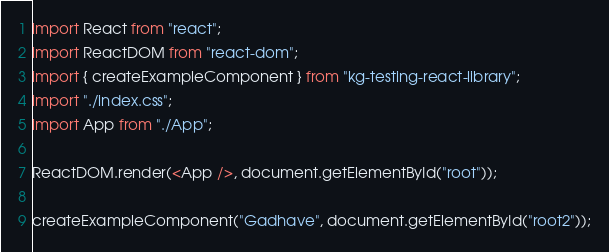Convert code to text. <code><loc_0><loc_0><loc_500><loc_500><_JavaScript_>import React from "react";
import ReactDOM from "react-dom";
import { createExampleComponent } from "kg-testing-react-library";
import "./index.css";
import App from "./App";

ReactDOM.render(<App />, document.getElementById("root"));

createExampleComponent("Gadhave", document.getElementById("root2"));
</code> 